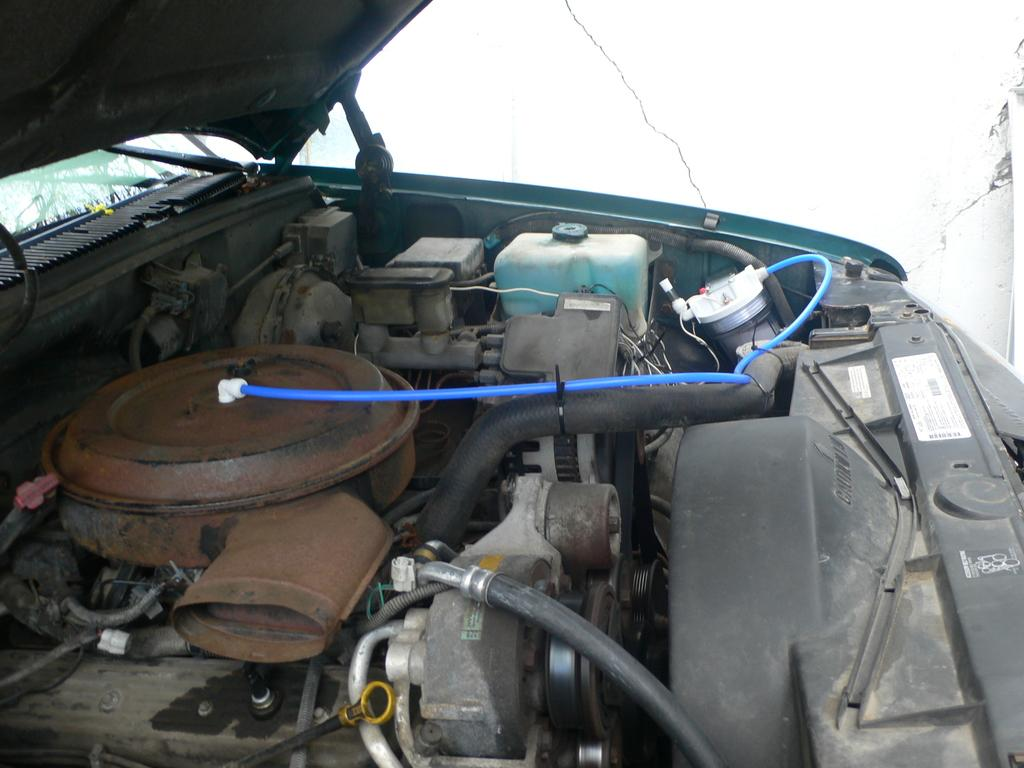What is the main subject of the image? The main subject of the image is the engine of a vehicle. What colors are the pipes in the engine? There are black and blue color pipes in the engine. What can be seen to the right of the engine in the image? There is a white wall visible to the right of the engine. How many cards are being played on the ship in the image? There is no ship or card game present in the image; it features the engine of a vehicle and a white wall. What type of folding technique is being used for the blue pipes in the image? The blue pipes in the image are not being folded; they are part of the engine's structure. 